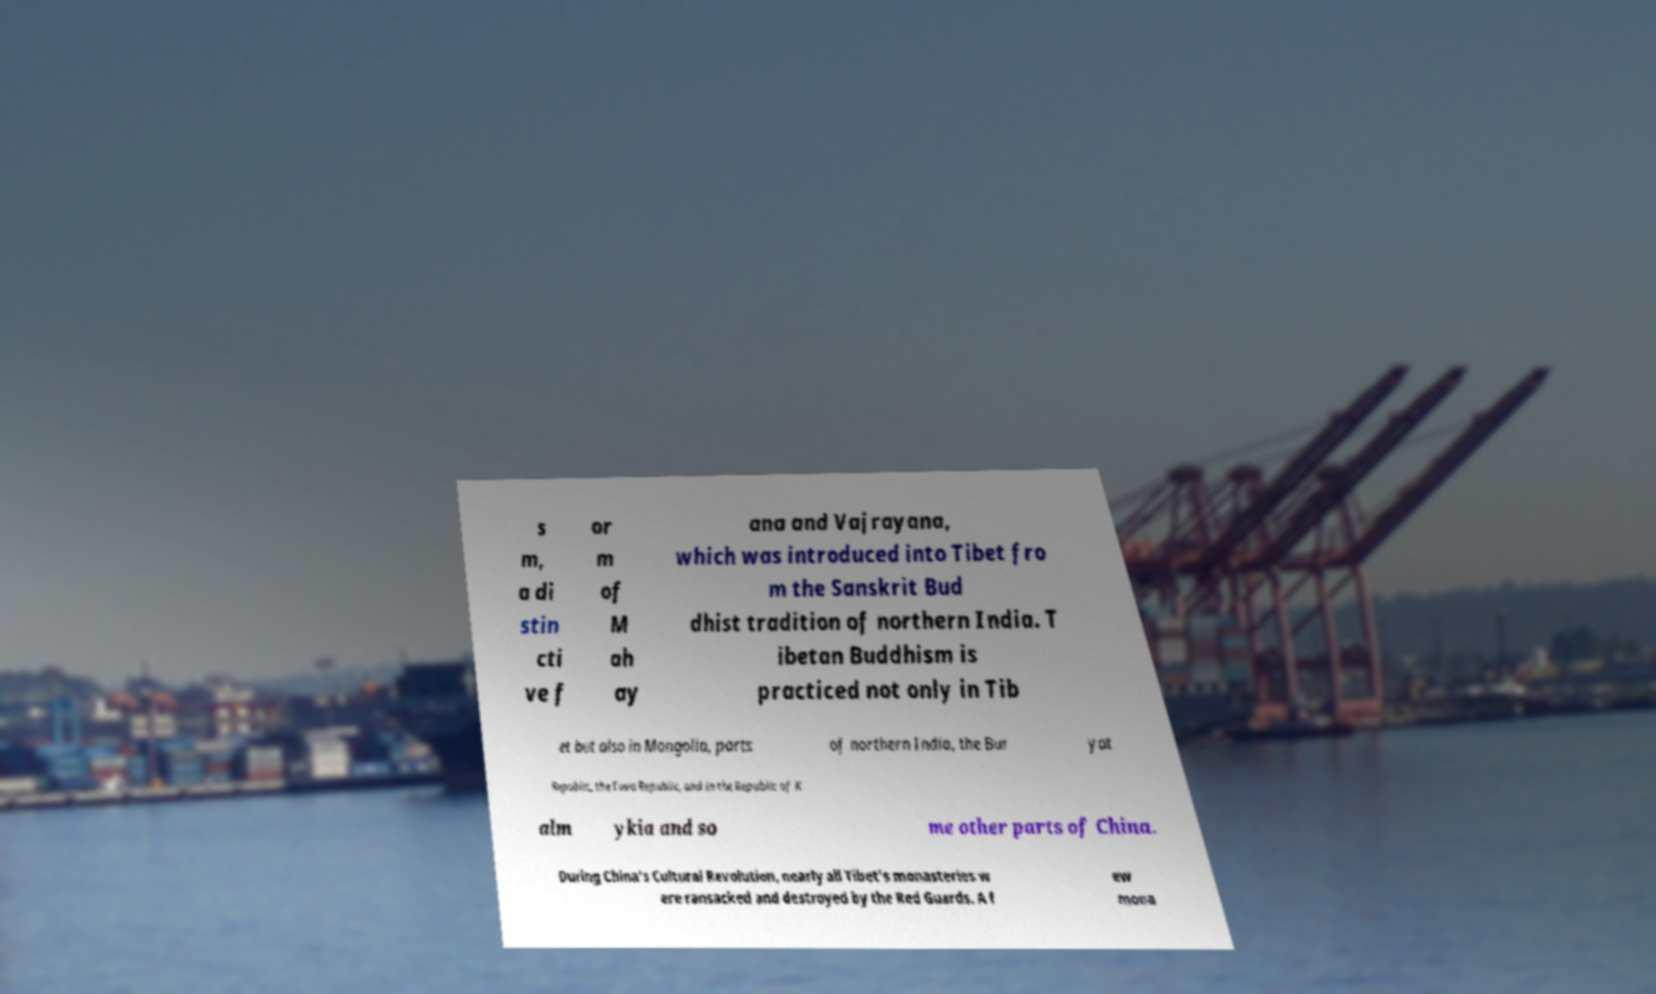I need the written content from this picture converted into text. Can you do that? s m, a di stin cti ve f or m of M ah ay ana and Vajrayana, which was introduced into Tibet fro m the Sanskrit Bud dhist tradition of northern India. T ibetan Buddhism is practiced not only in Tib et but also in Mongolia, parts of northern India, the Bur yat Republic, the Tuva Republic, and in the Republic of K alm ykia and so me other parts of China. During China's Cultural Revolution, nearly all Tibet's monasteries w ere ransacked and destroyed by the Red Guards. A f ew mona 